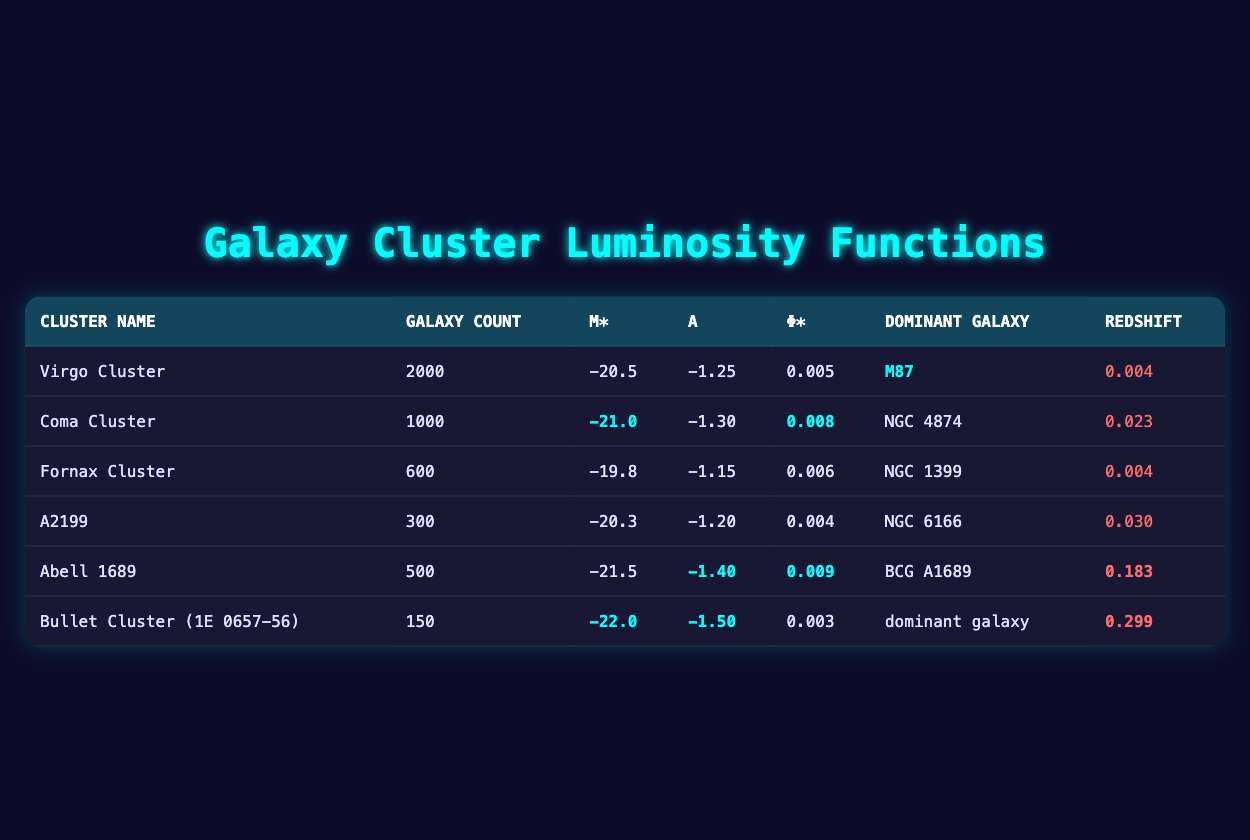What is the dominant galaxy in the Virgo Cluster? Looking at the table, under the row for the Virgo Cluster, the column labeled "Dominant Galaxy" shows "M87."
Answer: M87 How many galaxies are in the Coma Cluster? The table indicates that the galaxy count for the Coma Cluster is found in the corresponding row under the "Galaxy Count" column, which is 1000.
Answer: 1000 What is the M* value for Abell 1689? In the row for Abell 1689, the M* value is explicitly stated in the M* column, which is -21.5.
Answer: -21.5 Which cluster has the highest redshift value? By comparing the redshift values in the last column, the highest value listed is for the Bullet Cluster (1E 0657-56) at 0.299.
Answer: Bullet Cluster (1E 0657-56) What is the difference in galaxy count between the Virgo Cluster and the A2199 cluster? The galaxy count for the Virgo Cluster is 2000, and for A2199 it is 300. The difference is calculated as 2000 - 300 = 1700.
Answer: 1700 Is the alpha value for the Fornax Cluster greater than -1.25? The alpha value for the Fornax Cluster is -1.15, which is indeed greater than -1.25.
Answer: Yes What is the average M* value across all clusters? The M* values for all clusters are -20.5, -21.0, -19.8, -20.3, -21.5, and -22.0. Summing these gives -125.1, and dividing by 6 results in an average of -20.85.
Answer: -20.85 Which cluster has the highest luminosity function represented by φ*? Comparing φ* values in the table, Abell 1689 has the highest value at 0.009.
Answer: Abell 1689 What is the total galaxy count for Virgo, Coma, and Fornax clusters combined? Adding the galaxy counts for Virgo (2000), Coma (1000), and Fornax (600) gives a total of 2000 + 1000 + 600 = 3600.
Answer: 3600 Are there any clusters with a luminosity function parameter (α) lower than -1.5? By checking the α values, A2199 (-1.20), Virgo (-1.25), Fornax (-1.15), and Coma (-1.30) are all greater than -1.5, while Bullet Cluster (-1.50) is not lower, thus the answer is no.
Answer: No 